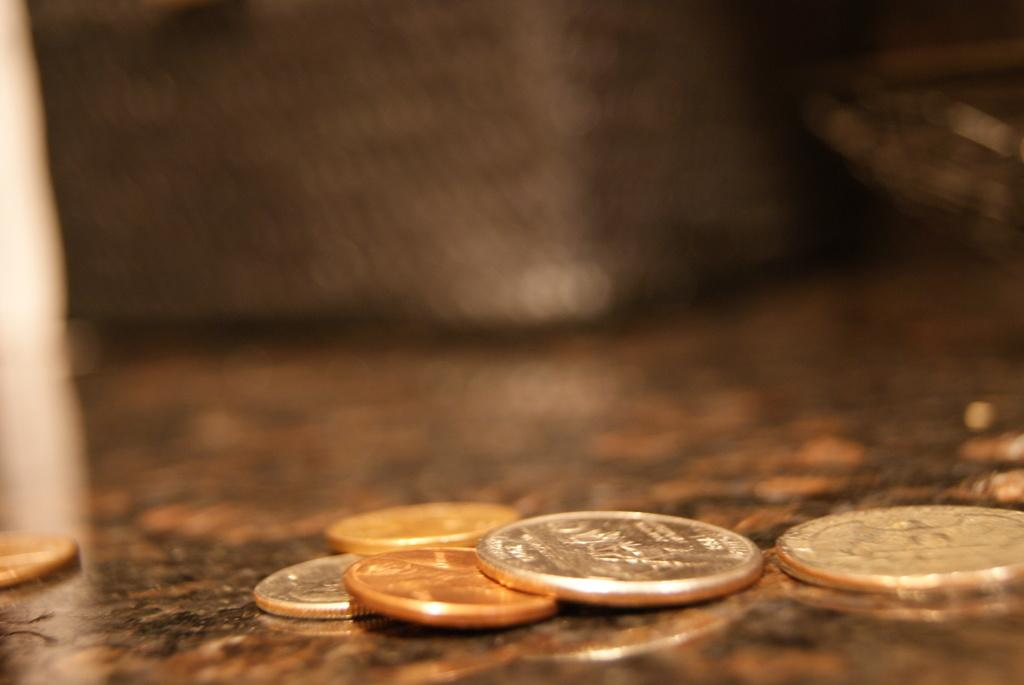What objects are on the table in the image? There are coins on the table in the image. What teaching method is being used to pull the coins in the image? There is no teaching method or pulling of coins present in the image; it only shows coins on a table. 